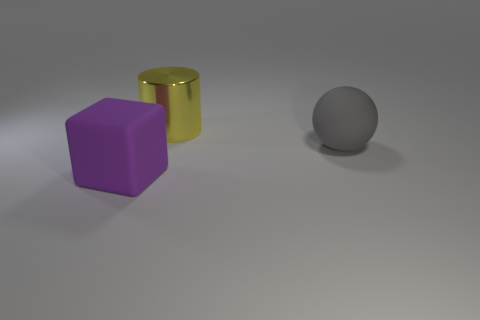There is a thing that is the same material as the large block; what color is it?
Offer a very short reply. Gray. Is the number of big purple matte objects that are to the left of the gray matte sphere less than the number of cylinders?
Make the answer very short. No. There is a thing that is the same material as the big ball; what is its shape?
Make the answer very short. Cube. How many rubber objects are either big yellow cylinders or gray objects?
Offer a terse response. 1. Are there an equal number of yellow metallic objects left of the big purple rubber block and large gray balls?
Your answer should be compact. No. Do the big matte object on the right side of the yellow shiny thing and the shiny cylinder have the same color?
Offer a very short reply. No. What is the large thing that is both behind the large cube and in front of the yellow metal object made of?
Give a very brief answer. Rubber. Is there a gray sphere in front of the large matte thing that is to the right of the large rubber cube?
Offer a terse response. No. Are the cube and the yellow object made of the same material?
Your answer should be very brief. No. There is a large thing that is behind the large purple rubber block and in front of the big yellow thing; what shape is it?
Your answer should be very brief. Sphere. 